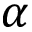Convert formula to latex. <formula><loc_0><loc_0><loc_500><loc_500>\alpha</formula> 